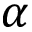Convert formula to latex. <formula><loc_0><loc_0><loc_500><loc_500>\alpha</formula> 